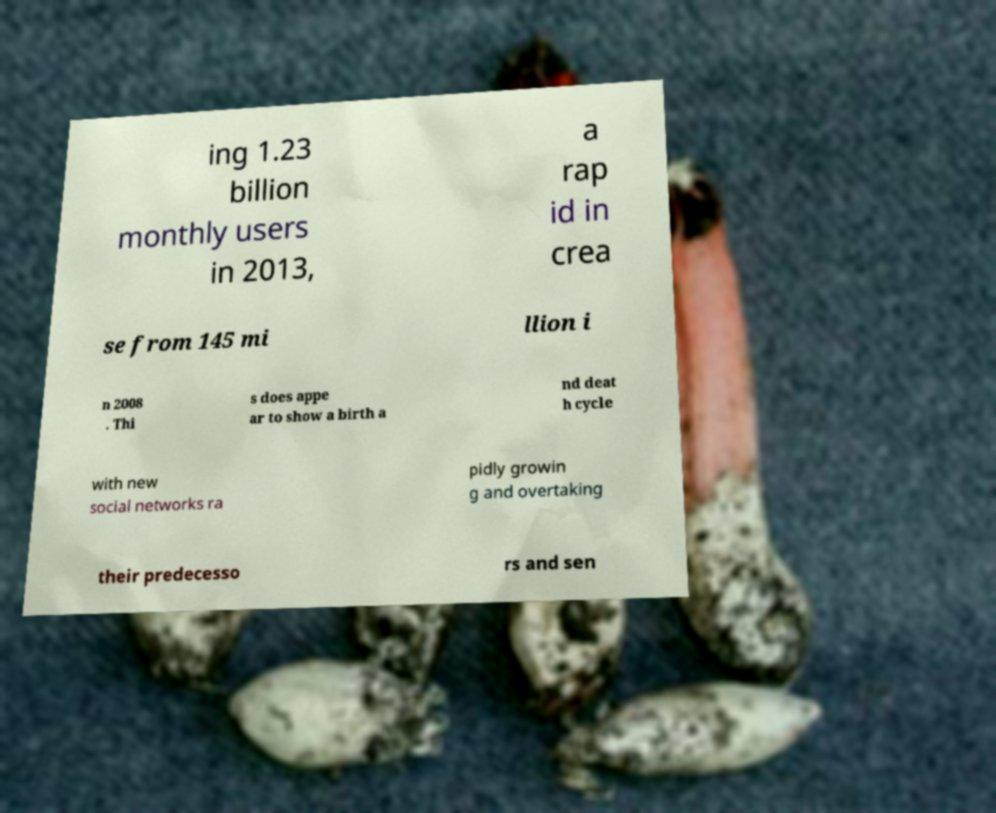Please identify and transcribe the text found in this image. ing 1.23 billion monthly users in 2013, a rap id in crea se from 145 mi llion i n 2008 . Thi s does appe ar to show a birth a nd deat h cycle with new social networks ra pidly growin g and overtaking their predecesso rs and sen 